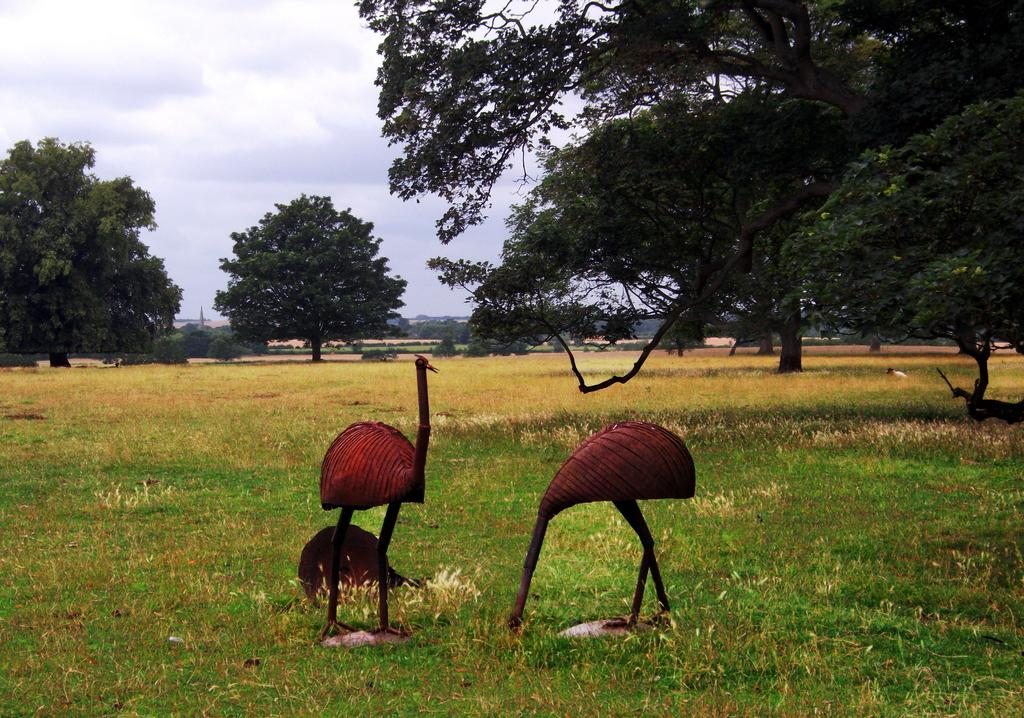How many birds are present in the image? There are two birds in the image. What is the location of the birds in relation to the grass? The birds are near the grass in the image. What can be seen in the background of the image? There are trees and plants in the background of the image. What is visible in the sky in the image? There are clouds in the sky in the image. What type of quiver can be seen hanging from the tree in the image? There is no quiver present in the image; it features two birds near grass with trees and plants in the background. 